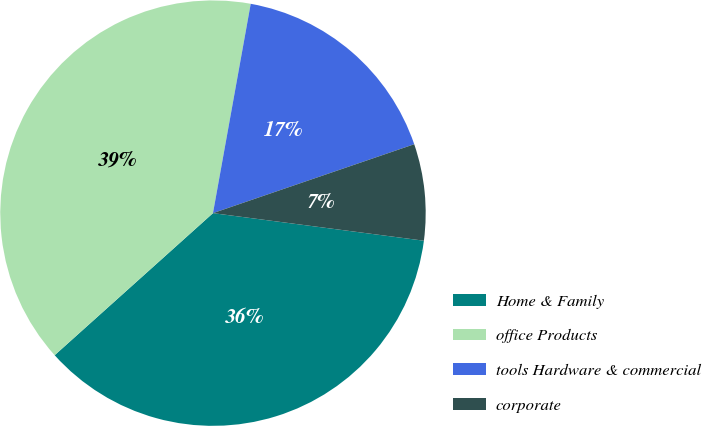<chart> <loc_0><loc_0><loc_500><loc_500><pie_chart><fcel>Home & Family<fcel>office Products<fcel>tools Hardware & commercial<fcel>corporate<nl><fcel>36.29%<fcel>39.48%<fcel>16.91%<fcel>7.32%<nl></chart> 